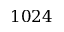<formula> <loc_0><loc_0><loc_500><loc_500>1 0 2 4</formula> 